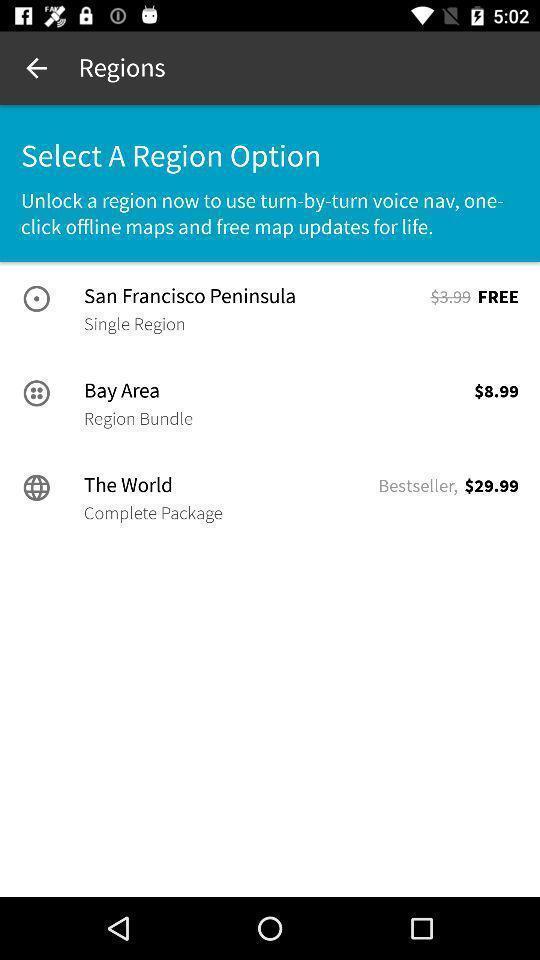Give me a narrative description of this picture. Screen displaying a list of regions with price. 